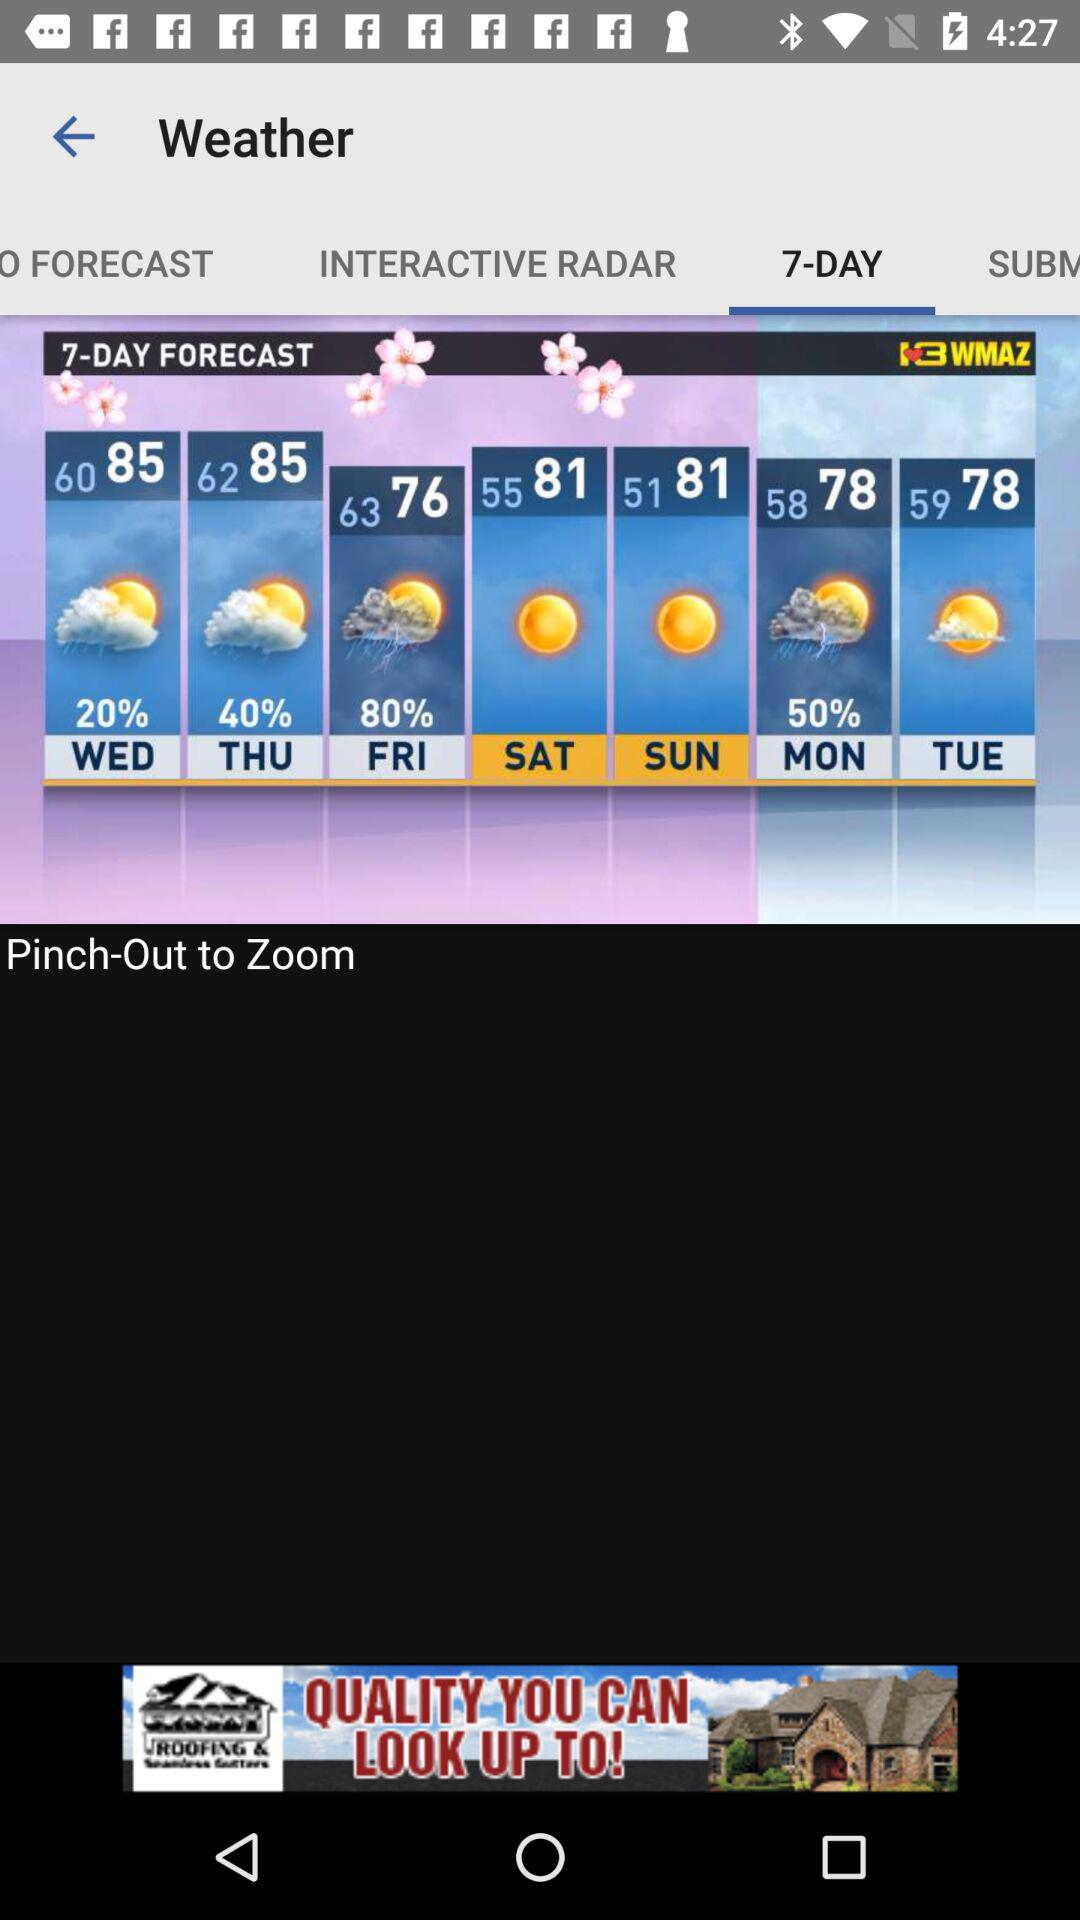Which tab am I on? You are on the "7-DAY" tab. 